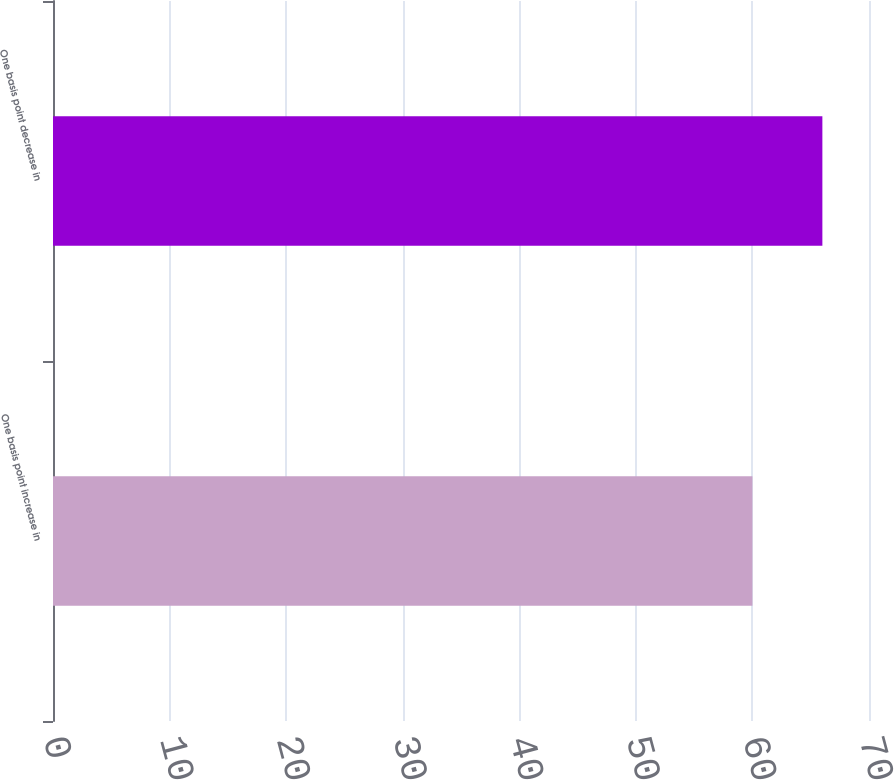Convert chart. <chart><loc_0><loc_0><loc_500><loc_500><bar_chart><fcel>One basis point increase in<fcel>One basis point decrease in<nl><fcel>60<fcel>66<nl></chart> 